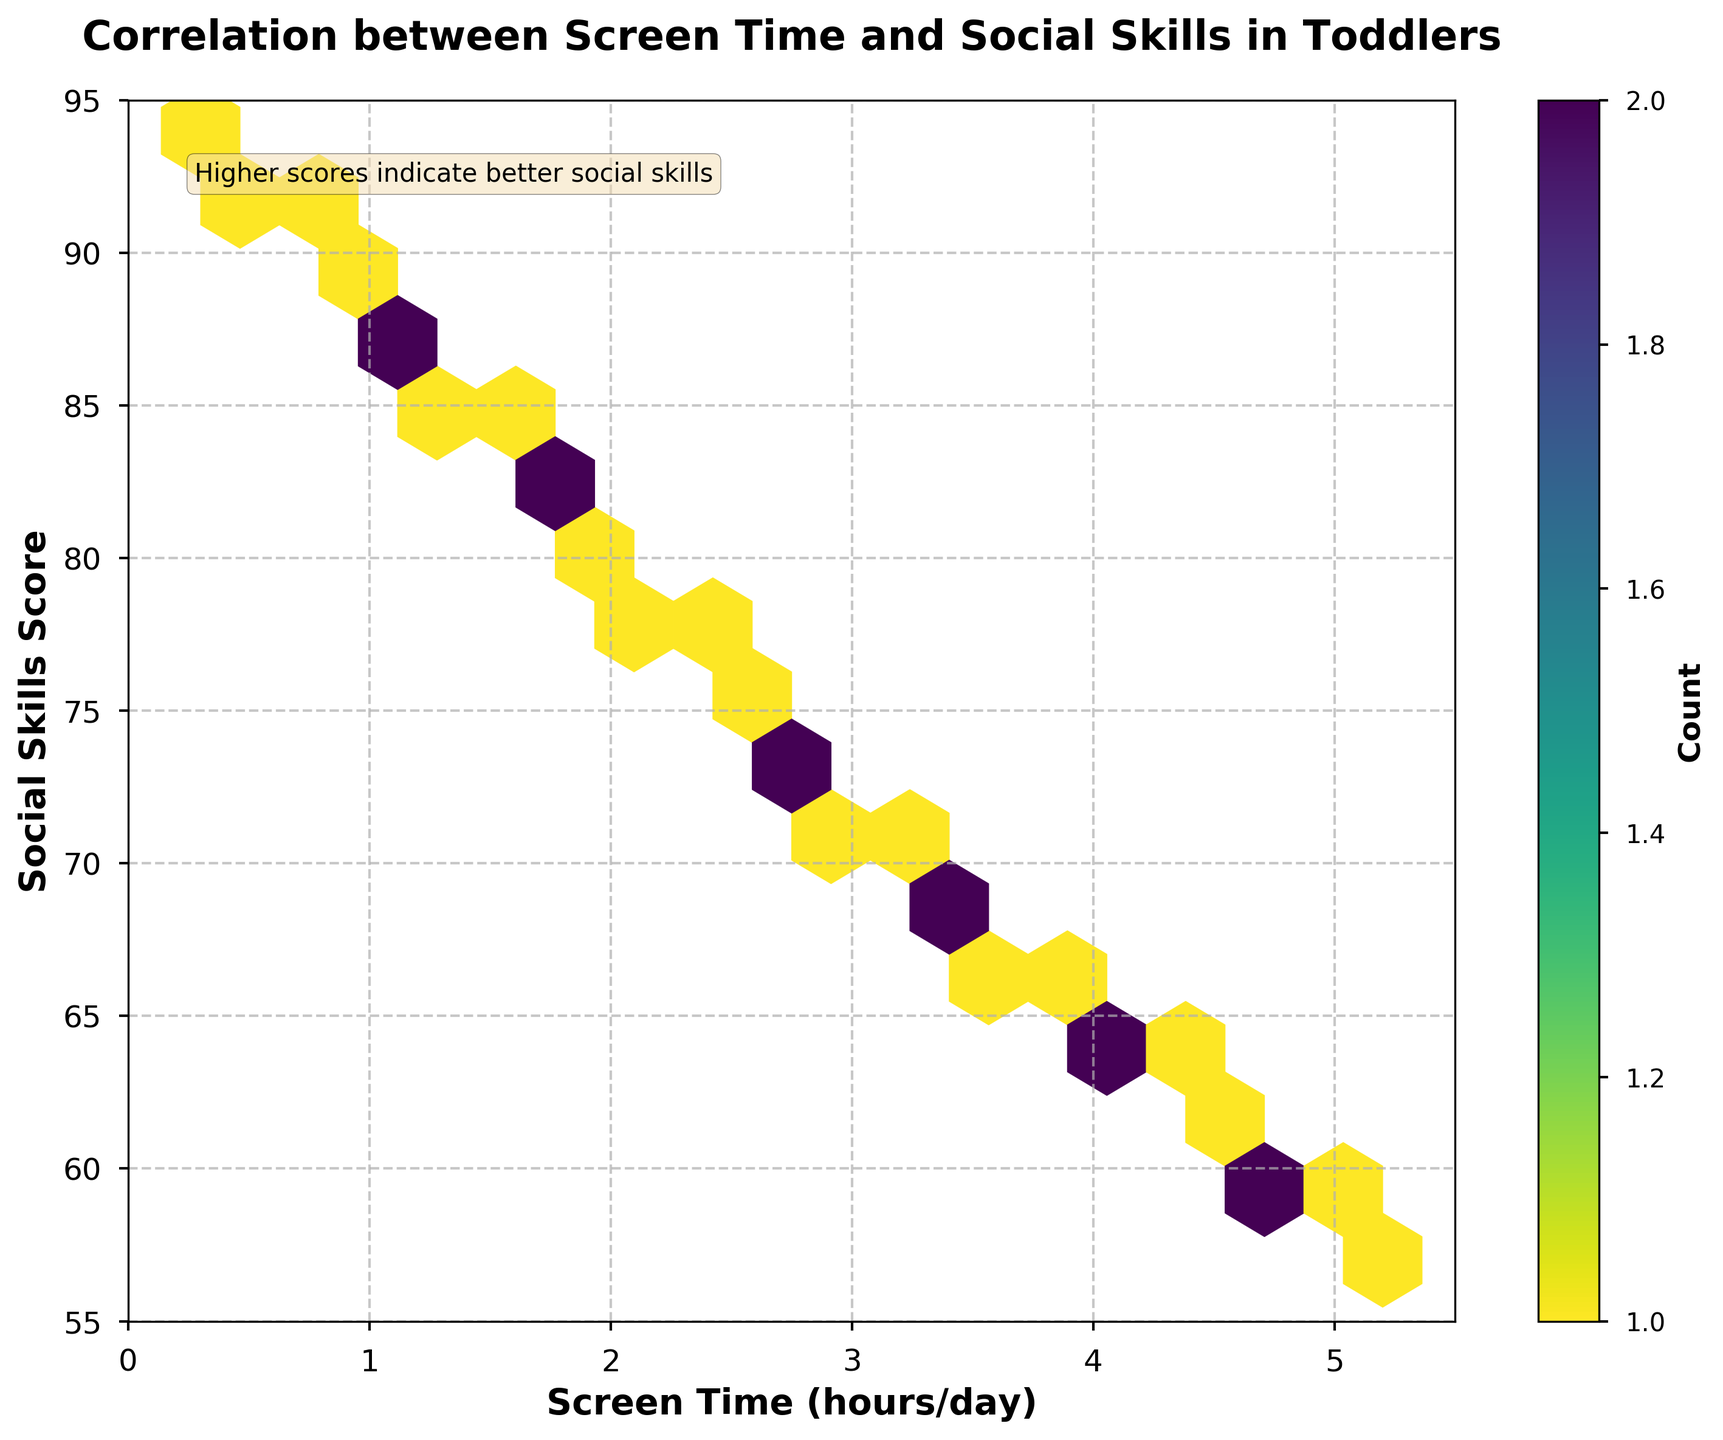What is the title of the plot? The title is usually found at the top of the figure in large, bold letters. Here, it states what the plot is about.
Answer: Correlation between Screen Time and Social Skills in Toddlers What do the axes represent? The x-axis typically represents the independent variable and the y-axis represents the dependent variable, as labeled in bold letters.
Answer: The x-axis represents Screen Time (hours/day) and the y-axis represents Social Skills Score (0-100) What does the color intensity in the hexbin plot indicate? In a hexbin plot, color intensity usually represents the number of data points within each hexagonal bin, as indicated by the color bar to the side of the figure.
Answer: The count of data points What is the general trend between screen time and social skills score observed in the plot? By examining the scatter of hexagons, we can determine if there's a visible trend, such as increasing or decreasing.
Answer: Generally, as screen time increases, social skills scores decrease How many data points are included in the figure? The color bar indicates the count of points in each hex. We can count the intervals and sum the counts to get the total number of data points.
Answer: 30 data points Is there any screen time range that seems to have more consistent social skills scores? By looking for clusters of hexagons with similar colors/scores, we can identify ranges with less variability.
Answer: Screen time between 0.5 and 1.5 hours/day Compare the social skills scores for toddlers with 1 hour/day and 4 hours/day of screen time. Identify the y-values corresponding to x-values of 1 and 4 in the plot and compare them.
Answer: 88 for 1 hour/day and 65 for 4 hours/day What is the social skills score for toddlers with 2.5 hours/day of screen time? Locate the specific point where screen time is 2.5 hours/day and read the corresponding social skills score.
Answer: 76 How does the frequency of data points change as screen time increases from 0 to 5 hours/day? Read from the color bar and look for changes in the concentration of hexagons through the range of screen time.
Answer: Frequency generally decreases What is the average social skills score for the toddlers in the dataset? Sum all social skills scores and divide by the number of data points. For brevity: (Sum of social skills scores) / 30.
Answer: 75.9 